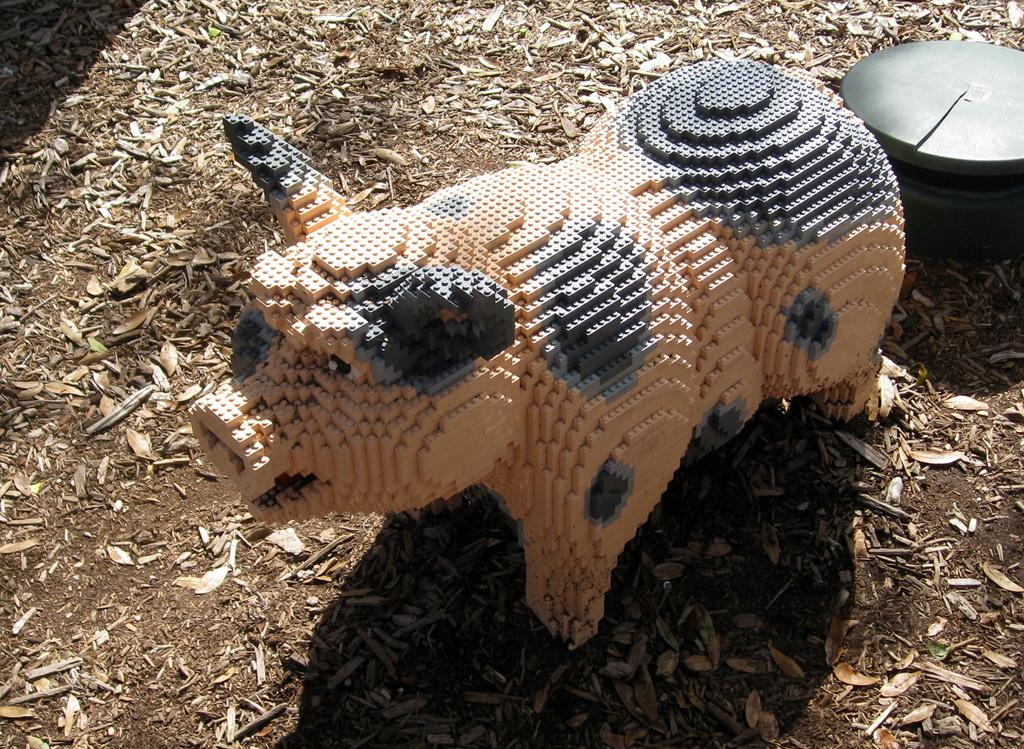What type of object is present in the image? There is an animal toy in the image. Where is the animal toy located? The animal toy is on the land. What type of natural debris can be seen in the image? There are dried leaves in the image. Can you describe the unspecified object in the image? Unfortunately, the facts provided do not give any details about the unspecified object, so we cannot describe it. What type of pie is being served by the hen in the image? There is no hen or pie present in the image; it features an animal toy on the land and dried leaves. 